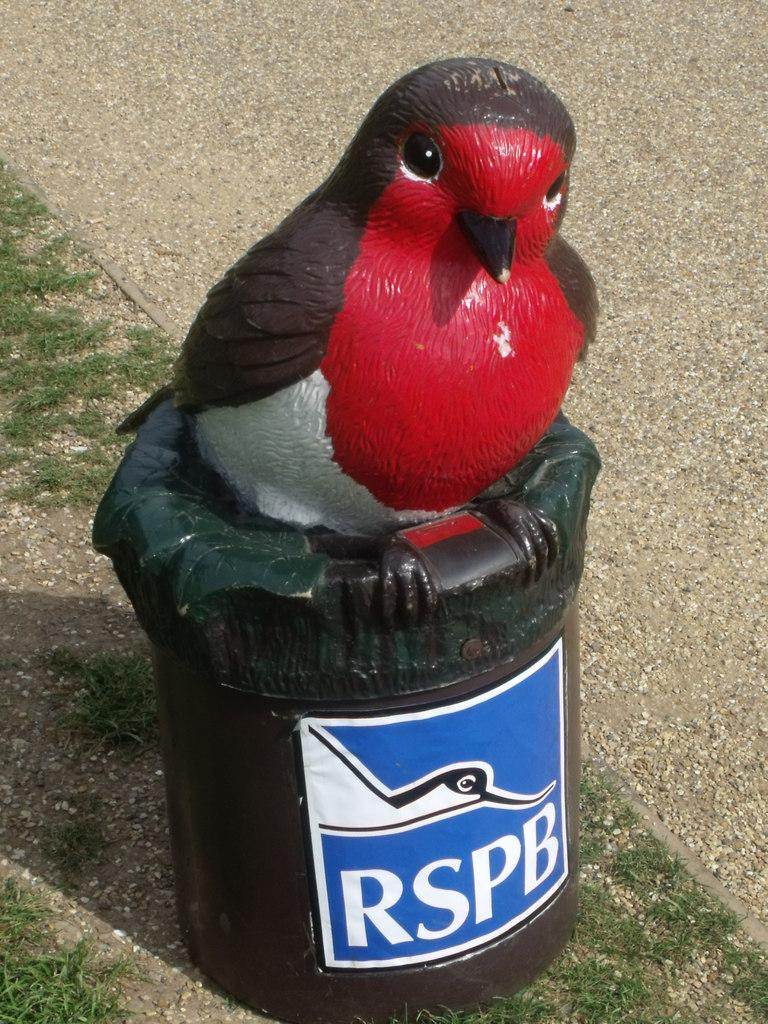What is the main subject of the image? The main subject of the image is a bird statue. What is the bird statue placed on? The bird statue is on a black color structure. Is there any text or information on the bird statue? Yes, there is a label on the bird statue. What type of environment can be seen in the background of the image? The background of the image shows land and grass. How many nerves can be seen connected to the bird statue in the image? There are no nerves visible in the image, as it features a bird statue on a black structure with a label. 